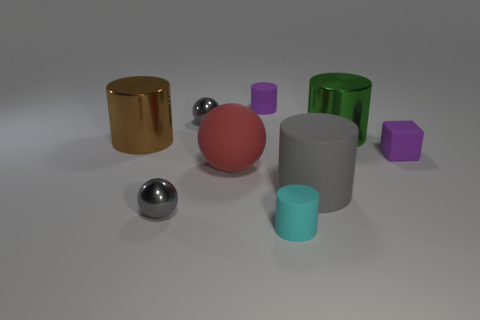There is a small gray object in front of the big matte sphere; is it the same shape as the big green metal thing? No, the small gray object in front of the big matte sphere is a smaller sphere, whereas the big green metal thing is cylindrical in shape. 